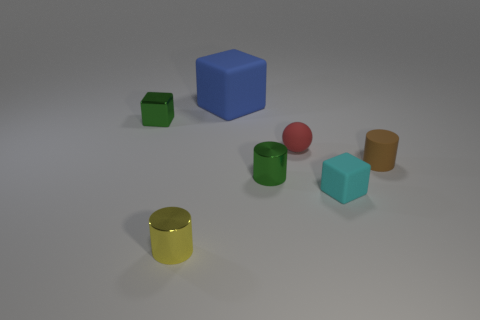Is there anything else that is the same size as the blue matte cube?
Give a very brief answer. No. What is the shape of the small matte object that is both in front of the small rubber sphere and on the left side of the brown object?
Your answer should be compact. Cube. The blue block that is made of the same material as the tiny red thing is what size?
Ensure brevity in your answer.  Large. Does the small sphere have the same color as the small matte object in front of the green metallic cylinder?
Your answer should be very brief. No. There is a cylinder that is both on the right side of the yellow cylinder and to the left of the tiny sphere; what is its material?
Give a very brief answer. Metal. Is the shape of the tiny green object to the right of the tiny yellow thing the same as the small yellow shiny thing that is in front of the blue matte object?
Provide a succinct answer. Yes. Are there any purple objects?
Provide a succinct answer. No. What is the color of the other rubber object that is the same shape as the big matte object?
Keep it short and to the point. Cyan. The rubber ball that is the same size as the brown object is what color?
Ensure brevity in your answer.  Red. Are the tiny green cube and the tiny green cylinder made of the same material?
Offer a very short reply. Yes. 